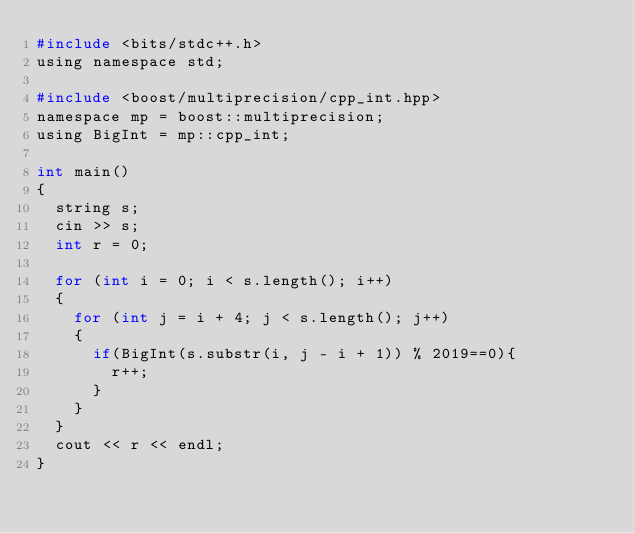<code> <loc_0><loc_0><loc_500><loc_500><_C_>#include <bits/stdc++.h>
using namespace std;

#include <boost/multiprecision/cpp_int.hpp>
namespace mp = boost::multiprecision;
using BigInt = mp::cpp_int;

int main()
{
  string s;
  cin >> s;
  int r = 0;

  for (int i = 0; i < s.length(); i++)
  {
    for (int j = i + 4; j < s.length(); j++)
    {
      if(BigInt(s.substr(i, j - i + 1)) % 2019==0){
        r++;
      }
    }
  }
  cout << r << endl;
}
</code> 